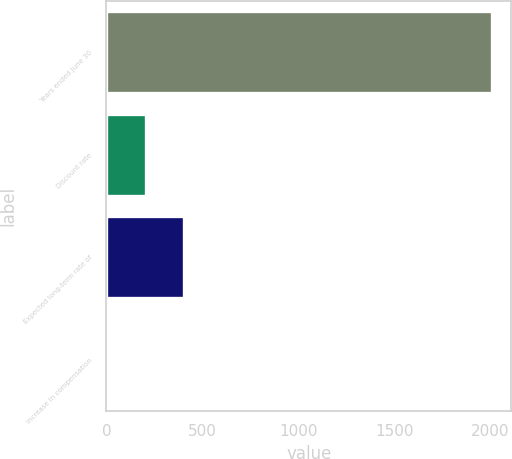<chart> <loc_0><loc_0><loc_500><loc_500><bar_chart><fcel>Years ended June 30<fcel>Discount rate<fcel>Expected long-term rate of<fcel>Increase in compensation<nl><fcel>2007<fcel>205.65<fcel>405.8<fcel>5.5<nl></chart> 